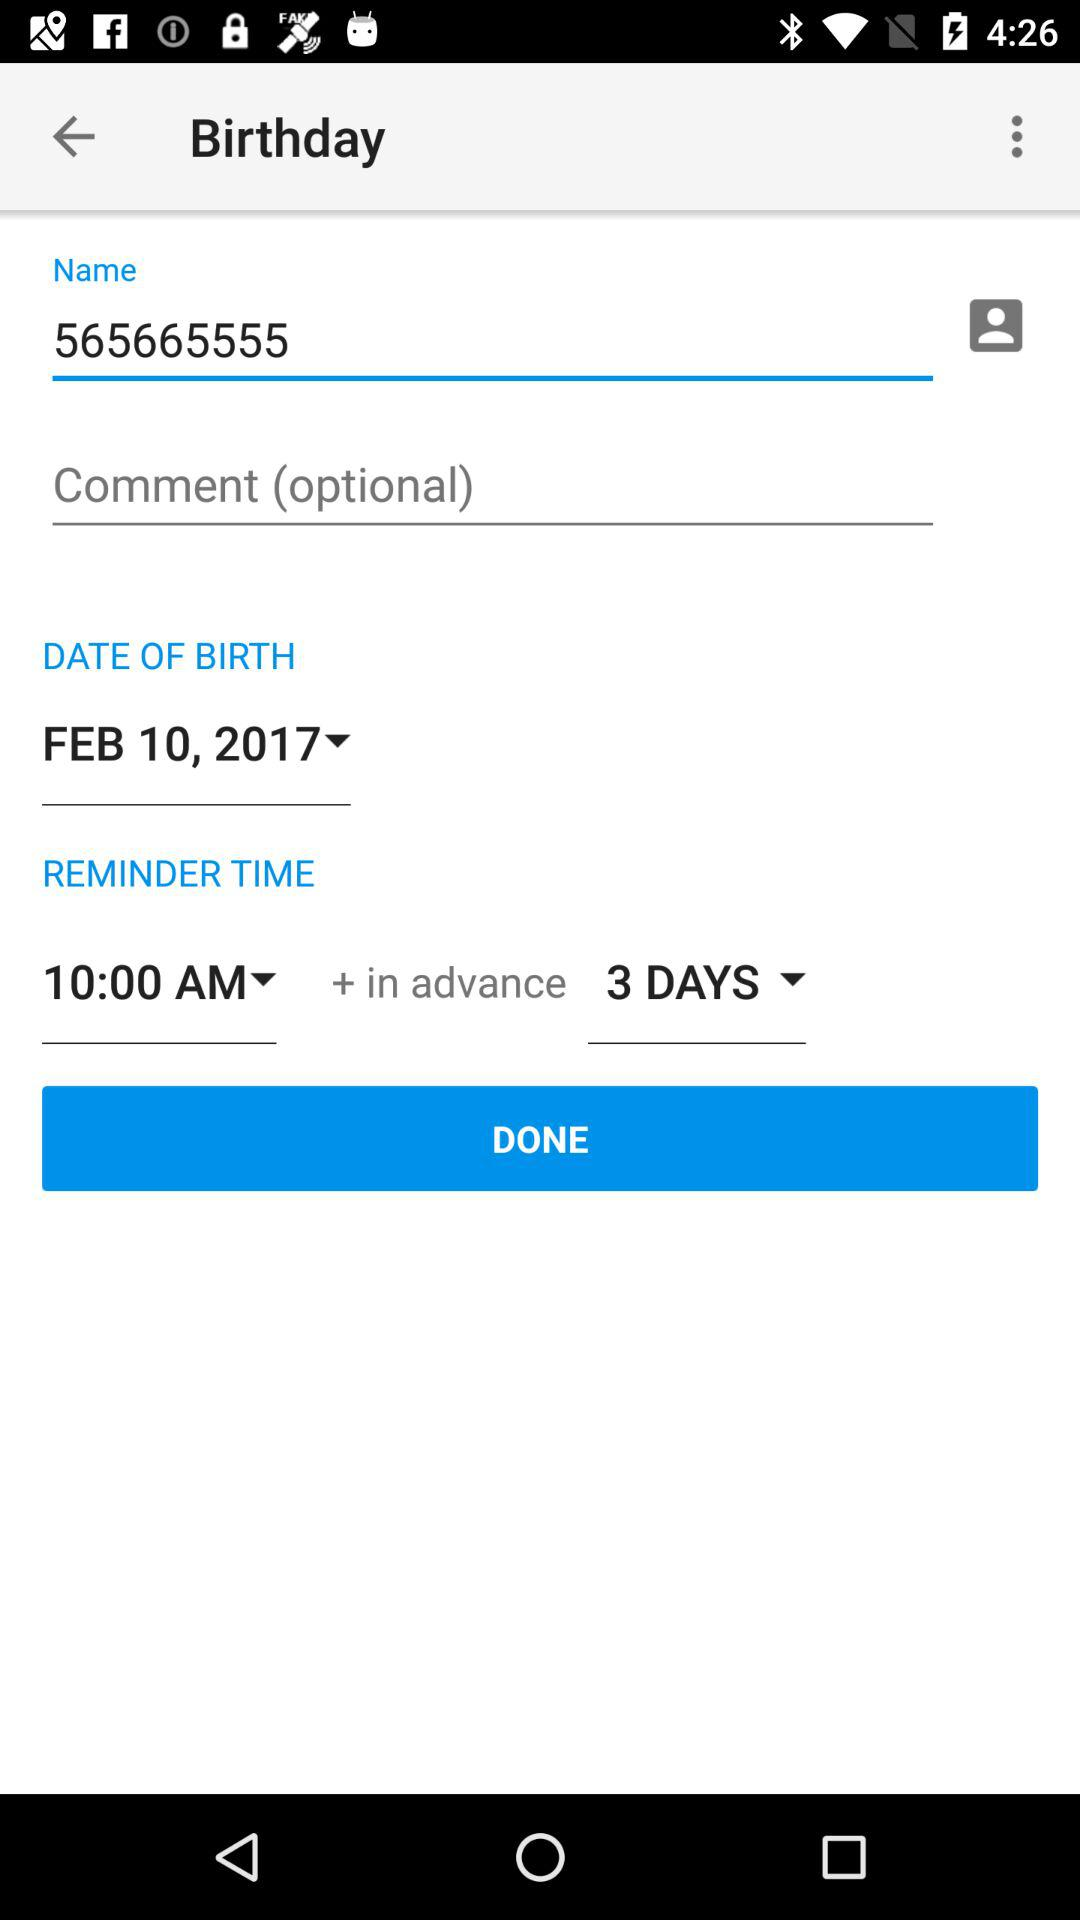What is the reminder time? The reminder time is 10:00 AM. 